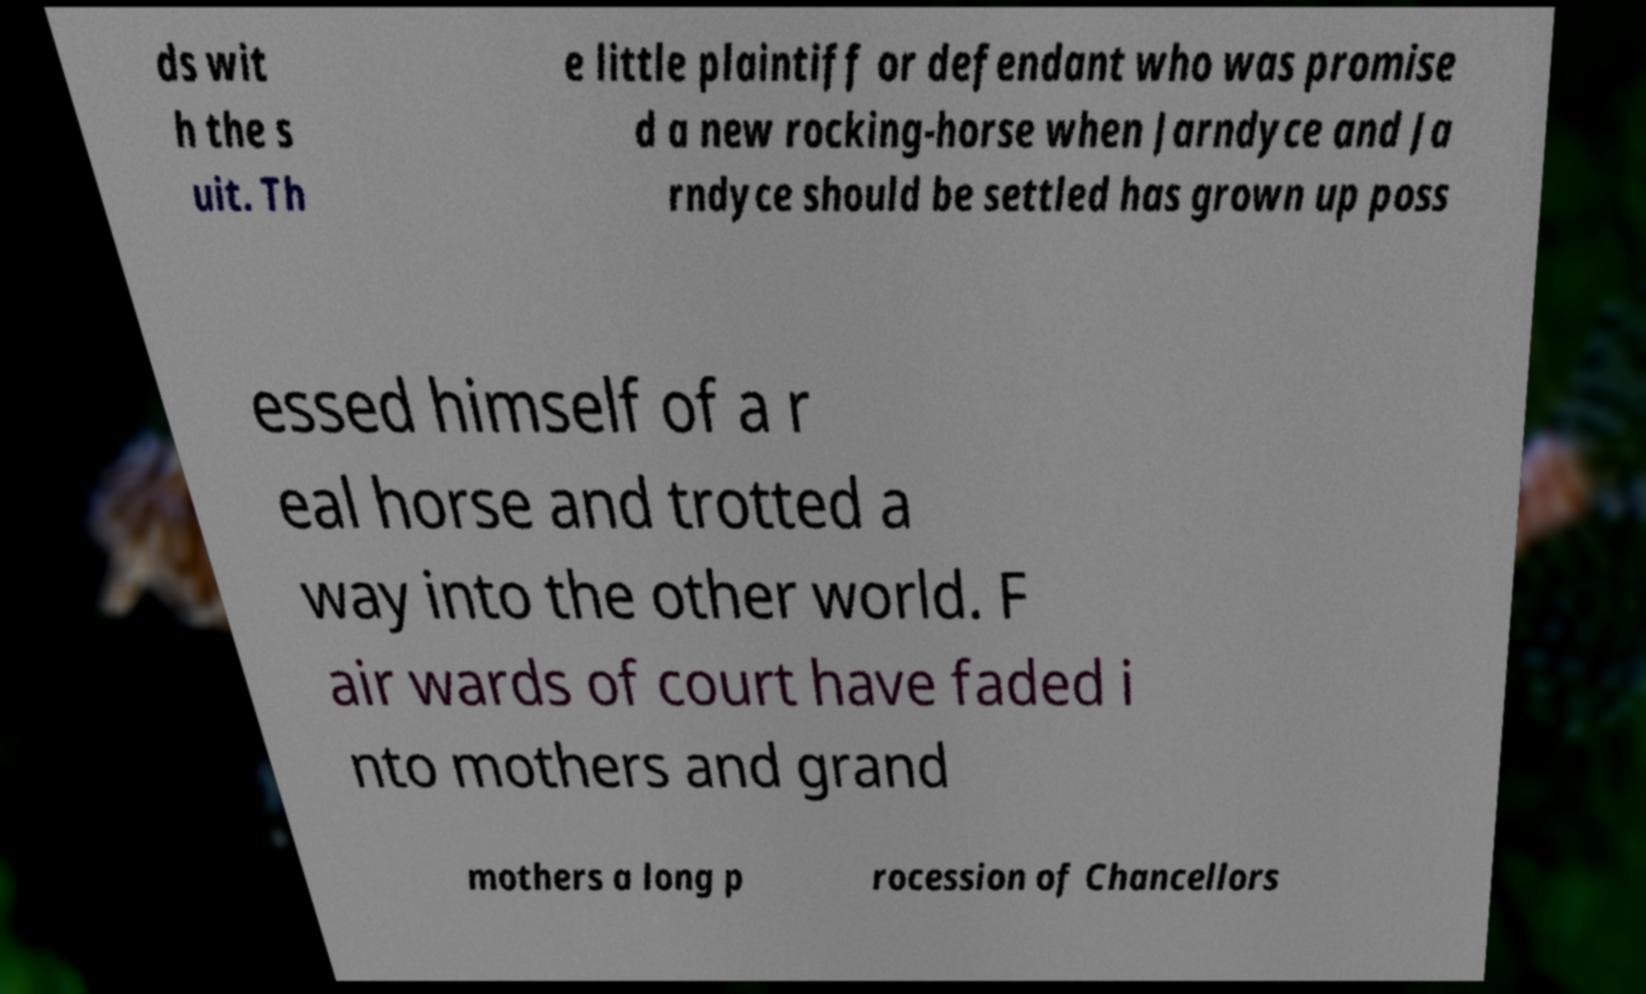Please read and relay the text visible in this image. What does it say? ds wit h the s uit. Th e little plaintiff or defendant who was promise d a new rocking-horse when Jarndyce and Ja rndyce should be settled has grown up poss essed himself of a r eal horse and trotted a way into the other world. F air wards of court have faded i nto mothers and grand mothers a long p rocession of Chancellors 